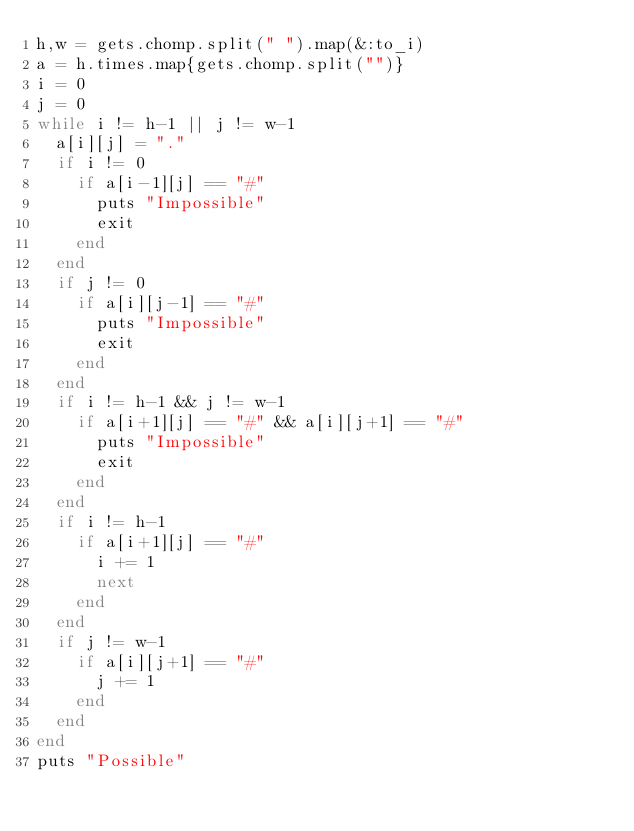Convert code to text. <code><loc_0><loc_0><loc_500><loc_500><_Ruby_>h,w = gets.chomp.split(" ").map(&:to_i)
a = h.times.map{gets.chomp.split("")}
i = 0
j = 0
while i != h-1 || j != w-1
  a[i][j] = "."
  if i != 0
    if a[i-1][j] == "#"
      puts "Impossible"
      exit
    end
  end
  if j != 0
    if a[i][j-1] == "#"
      puts "Impossible"
      exit
    end
  end
  if i != h-1 && j != w-1
    if a[i+1][j] == "#" && a[i][j+1] == "#"
      puts "Impossible"
      exit
    end
  end
  if i != h-1
    if a[i+1][j] == "#"
      i += 1
      next
    end
  end
  if j != w-1
    if a[i][j+1] == "#"
      j += 1
    end
  end
end
puts "Possible"</code> 